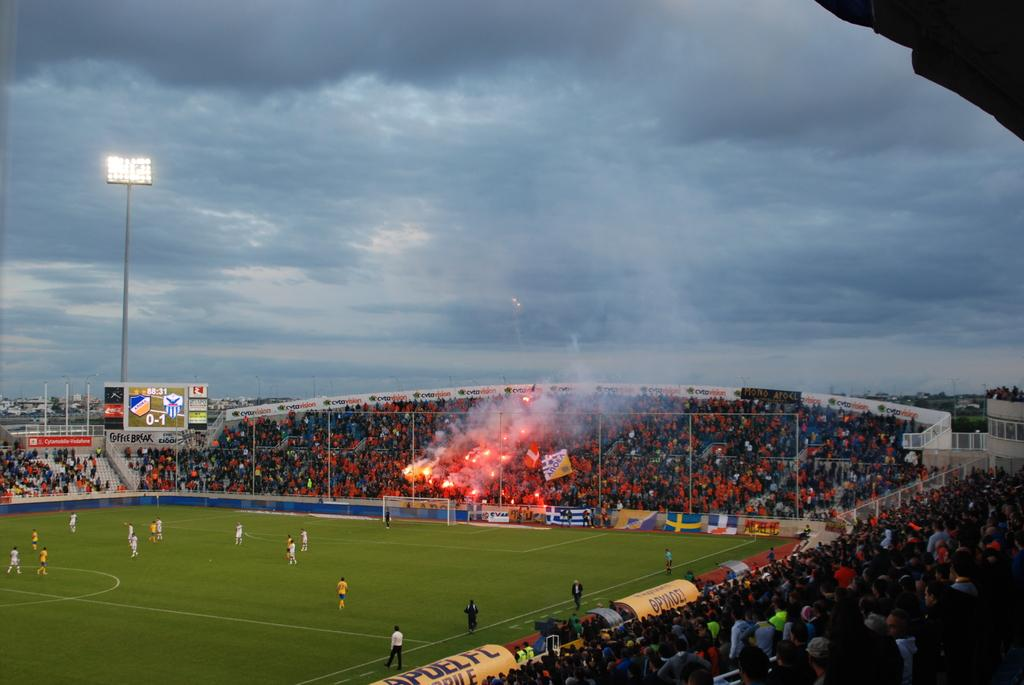<image>
Render a clear and concise summary of the photo. In a sports stadium, a COFFEE BREAK advertisement is visible below the scoreboard. 